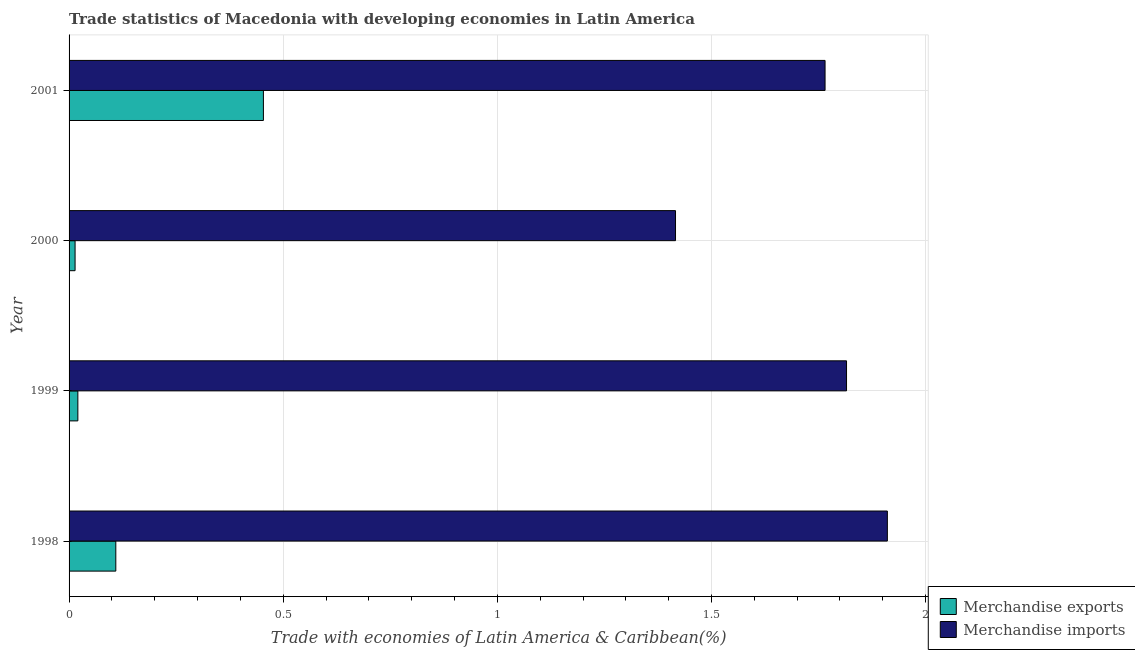How many different coloured bars are there?
Keep it short and to the point. 2. Are the number of bars per tick equal to the number of legend labels?
Give a very brief answer. Yes. Are the number of bars on each tick of the Y-axis equal?
Your answer should be very brief. Yes. How many bars are there on the 4th tick from the top?
Ensure brevity in your answer.  2. How many bars are there on the 1st tick from the bottom?
Ensure brevity in your answer.  2. What is the label of the 1st group of bars from the top?
Your answer should be very brief. 2001. What is the merchandise exports in 1999?
Your answer should be very brief. 0.02. Across all years, what is the maximum merchandise imports?
Offer a very short reply. 1.91. Across all years, what is the minimum merchandise imports?
Provide a short and direct response. 1.42. What is the total merchandise exports in the graph?
Your answer should be very brief. 0.6. What is the difference between the merchandise imports in 1998 and that in 2000?
Offer a terse response. 0.49. What is the difference between the merchandise imports in 1999 and the merchandise exports in 2000?
Your answer should be very brief. 1.8. What is the average merchandise exports per year?
Offer a terse response. 0.15. In the year 1998, what is the difference between the merchandise exports and merchandise imports?
Offer a terse response. -1.8. In how many years, is the merchandise exports greater than 1.8 %?
Provide a succinct answer. 0. What is the ratio of the merchandise exports in 1999 to that in 2001?
Provide a short and direct response. 0.04. Is the merchandise imports in 1999 less than that in 2001?
Keep it short and to the point. No. Is the difference between the merchandise imports in 1998 and 2000 greater than the difference between the merchandise exports in 1998 and 2000?
Ensure brevity in your answer.  Yes. What is the difference between the highest and the second highest merchandise exports?
Provide a short and direct response. 0.34. What is the difference between the highest and the lowest merchandise exports?
Offer a very short reply. 0.44. In how many years, is the merchandise exports greater than the average merchandise exports taken over all years?
Provide a short and direct response. 1. What does the 1st bar from the bottom in 1999 represents?
Make the answer very short. Merchandise exports. Are all the bars in the graph horizontal?
Your response must be concise. Yes. How many years are there in the graph?
Give a very brief answer. 4. What is the difference between two consecutive major ticks on the X-axis?
Your response must be concise. 0.5. Where does the legend appear in the graph?
Provide a short and direct response. Bottom right. How are the legend labels stacked?
Keep it short and to the point. Vertical. What is the title of the graph?
Make the answer very short. Trade statistics of Macedonia with developing economies in Latin America. Does "Methane" appear as one of the legend labels in the graph?
Give a very brief answer. No. What is the label or title of the X-axis?
Your answer should be very brief. Trade with economies of Latin America & Caribbean(%). What is the label or title of the Y-axis?
Give a very brief answer. Year. What is the Trade with economies of Latin America & Caribbean(%) in Merchandise exports in 1998?
Offer a very short reply. 0.11. What is the Trade with economies of Latin America & Caribbean(%) of Merchandise imports in 1998?
Ensure brevity in your answer.  1.91. What is the Trade with economies of Latin America & Caribbean(%) in Merchandise exports in 1999?
Provide a succinct answer. 0.02. What is the Trade with economies of Latin America & Caribbean(%) in Merchandise imports in 1999?
Your response must be concise. 1.82. What is the Trade with economies of Latin America & Caribbean(%) of Merchandise exports in 2000?
Give a very brief answer. 0.01. What is the Trade with economies of Latin America & Caribbean(%) in Merchandise imports in 2000?
Give a very brief answer. 1.42. What is the Trade with economies of Latin America & Caribbean(%) in Merchandise exports in 2001?
Give a very brief answer. 0.45. What is the Trade with economies of Latin America & Caribbean(%) of Merchandise imports in 2001?
Provide a succinct answer. 1.77. Across all years, what is the maximum Trade with economies of Latin America & Caribbean(%) of Merchandise exports?
Ensure brevity in your answer.  0.45. Across all years, what is the maximum Trade with economies of Latin America & Caribbean(%) in Merchandise imports?
Offer a terse response. 1.91. Across all years, what is the minimum Trade with economies of Latin America & Caribbean(%) of Merchandise exports?
Your answer should be very brief. 0.01. Across all years, what is the minimum Trade with economies of Latin America & Caribbean(%) of Merchandise imports?
Your answer should be compact. 1.42. What is the total Trade with economies of Latin America & Caribbean(%) of Merchandise exports in the graph?
Offer a very short reply. 0.6. What is the total Trade with economies of Latin America & Caribbean(%) in Merchandise imports in the graph?
Your response must be concise. 6.91. What is the difference between the Trade with economies of Latin America & Caribbean(%) of Merchandise exports in 1998 and that in 1999?
Your response must be concise. 0.09. What is the difference between the Trade with economies of Latin America & Caribbean(%) of Merchandise imports in 1998 and that in 1999?
Provide a short and direct response. 0.1. What is the difference between the Trade with economies of Latin America & Caribbean(%) of Merchandise exports in 1998 and that in 2000?
Keep it short and to the point. 0.1. What is the difference between the Trade with economies of Latin America & Caribbean(%) of Merchandise imports in 1998 and that in 2000?
Your response must be concise. 0.49. What is the difference between the Trade with economies of Latin America & Caribbean(%) of Merchandise exports in 1998 and that in 2001?
Offer a very short reply. -0.34. What is the difference between the Trade with economies of Latin America & Caribbean(%) of Merchandise imports in 1998 and that in 2001?
Your response must be concise. 0.15. What is the difference between the Trade with economies of Latin America & Caribbean(%) of Merchandise exports in 1999 and that in 2000?
Keep it short and to the point. 0.01. What is the difference between the Trade with economies of Latin America & Caribbean(%) of Merchandise imports in 1999 and that in 2000?
Make the answer very short. 0.4. What is the difference between the Trade with economies of Latin America & Caribbean(%) of Merchandise exports in 1999 and that in 2001?
Give a very brief answer. -0.43. What is the difference between the Trade with economies of Latin America & Caribbean(%) of Merchandise imports in 1999 and that in 2001?
Keep it short and to the point. 0.05. What is the difference between the Trade with economies of Latin America & Caribbean(%) in Merchandise exports in 2000 and that in 2001?
Provide a succinct answer. -0.44. What is the difference between the Trade with economies of Latin America & Caribbean(%) in Merchandise imports in 2000 and that in 2001?
Ensure brevity in your answer.  -0.35. What is the difference between the Trade with economies of Latin America & Caribbean(%) of Merchandise exports in 1998 and the Trade with economies of Latin America & Caribbean(%) of Merchandise imports in 1999?
Offer a very short reply. -1.71. What is the difference between the Trade with economies of Latin America & Caribbean(%) of Merchandise exports in 1998 and the Trade with economies of Latin America & Caribbean(%) of Merchandise imports in 2000?
Offer a terse response. -1.31. What is the difference between the Trade with economies of Latin America & Caribbean(%) of Merchandise exports in 1998 and the Trade with economies of Latin America & Caribbean(%) of Merchandise imports in 2001?
Your answer should be compact. -1.66. What is the difference between the Trade with economies of Latin America & Caribbean(%) in Merchandise exports in 1999 and the Trade with economies of Latin America & Caribbean(%) in Merchandise imports in 2000?
Offer a terse response. -1.4. What is the difference between the Trade with economies of Latin America & Caribbean(%) in Merchandise exports in 1999 and the Trade with economies of Latin America & Caribbean(%) in Merchandise imports in 2001?
Give a very brief answer. -1.74. What is the difference between the Trade with economies of Latin America & Caribbean(%) in Merchandise exports in 2000 and the Trade with economies of Latin America & Caribbean(%) in Merchandise imports in 2001?
Offer a terse response. -1.75. What is the average Trade with economies of Latin America & Caribbean(%) of Merchandise exports per year?
Provide a succinct answer. 0.15. What is the average Trade with economies of Latin America & Caribbean(%) of Merchandise imports per year?
Ensure brevity in your answer.  1.73. In the year 1998, what is the difference between the Trade with economies of Latin America & Caribbean(%) in Merchandise exports and Trade with economies of Latin America & Caribbean(%) in Merchandise imports?
Provide a succinct answer. -1.8. In the year 1999, what is the difference between the Trade with economies of Latin America & Caribbean(%) in Merchandise exports and Trade with economies of Latin America & Caribbean(%) in Merchandise imports?
Your answer should be very brief. -1.79. In the year 2000, what is the difference between the Trade with economies of Latin America & Caribbean(%) in Merchandise exports and Trade with economies of Latin America & Caribbean(%) in Merchandise imports?
Keep it short and to the point. -1.4. In the year 2001, what is the difference between the Trade with economies of Latin America & Caribbean(%) of Merchandise exports and Trade with economies of Latin America & Caribbean(%) of Merchandise imports?
Offer a very short reply. -1.31. What is the ratio of the Trade with economies of Latin America & Caribbean(%) in Merchandise exports in 1998 to that in 1999?
Offer a terse response. 5.32. What is the ratio of the Trade with economies of Latin America & Caribbean(%) in Merchandise imports in 1998 to that in 1999?
Make the answer very short. 1.05. What is the ratio of the Trade with economies of Latin America & Caribbean(%) in Merchandise exports in 1998 to that in 2000?
Your answer should be compact. 7.78. What is the ratio of the Trade with economies of Latin America & Caribbean(%) in Merchandise imports in 1998 to that in 2000?
Your answer should be very brief. 1.35. What is the ratio of the Trade with economies of Latin America & Caribbean(%) of Merchandise exports in 1998 to that in 2001?
Ensure brevity in your answer.  0.24. What is the ratio of the Trade with economies of Latin America & Caribbean(%) in Merchandise imports in 1998 to that in 2001?
Make the answer very short. 1.08. What is the ratio of the Trade with economies of Latin America & Caribbean(%) of Merchandise exports in 1999 to that in 2000?
Provide a short and direct response. 1.46. What is the ratio of the Trade with economies of Latin America & Caribbean(%) of Merchandise imports in 1999 to that in 2000?
Provide a short and direct response. 1.28. What is the ratio of the Trade with economies of Latin America & Caribbean(%) of Merchandise exports in 1999 to that in 2001?
Make the answer very short. 0.05. What is the ratio of the Trade with economies of Latin America & Caribbean(%) of Merchandise imports in 1999 to that in 2001?
Your response must be concise. 1.03. What is the ratio of the Trade with economies of Latin America & Caribbean(%) of Merchandise exports in 2000 to that in 2001?
Keep it short and to the point. 0.03. What is the ratio of the Trade with economies of Latin America & Caribbean(%) in Merchandise imports in 2000 to that in 2001?
Your answer should be compact. 0.8. What is the difference between the highest and the second highest Trade with economies of Latin America & Caribbean(%) in Merchandise exports?
Offer a very short reply. 0.34. What is the difference between the highest and the second highest Trade with economies of Latin America & Caribbean(%) in Merchandise imports?
Provide a succinct answer. 0.1. What is the difference between the highest and the lowest Trade with economies of Latin America & Caribbean(%) of Merchandise exports?
Keep it short and to the point. 0.44. What is the difference between the highest and the lowest Trade with economies of Latin America & Caribbean(%) in Merchandise imports?
Make the answer very short. 0.49. 